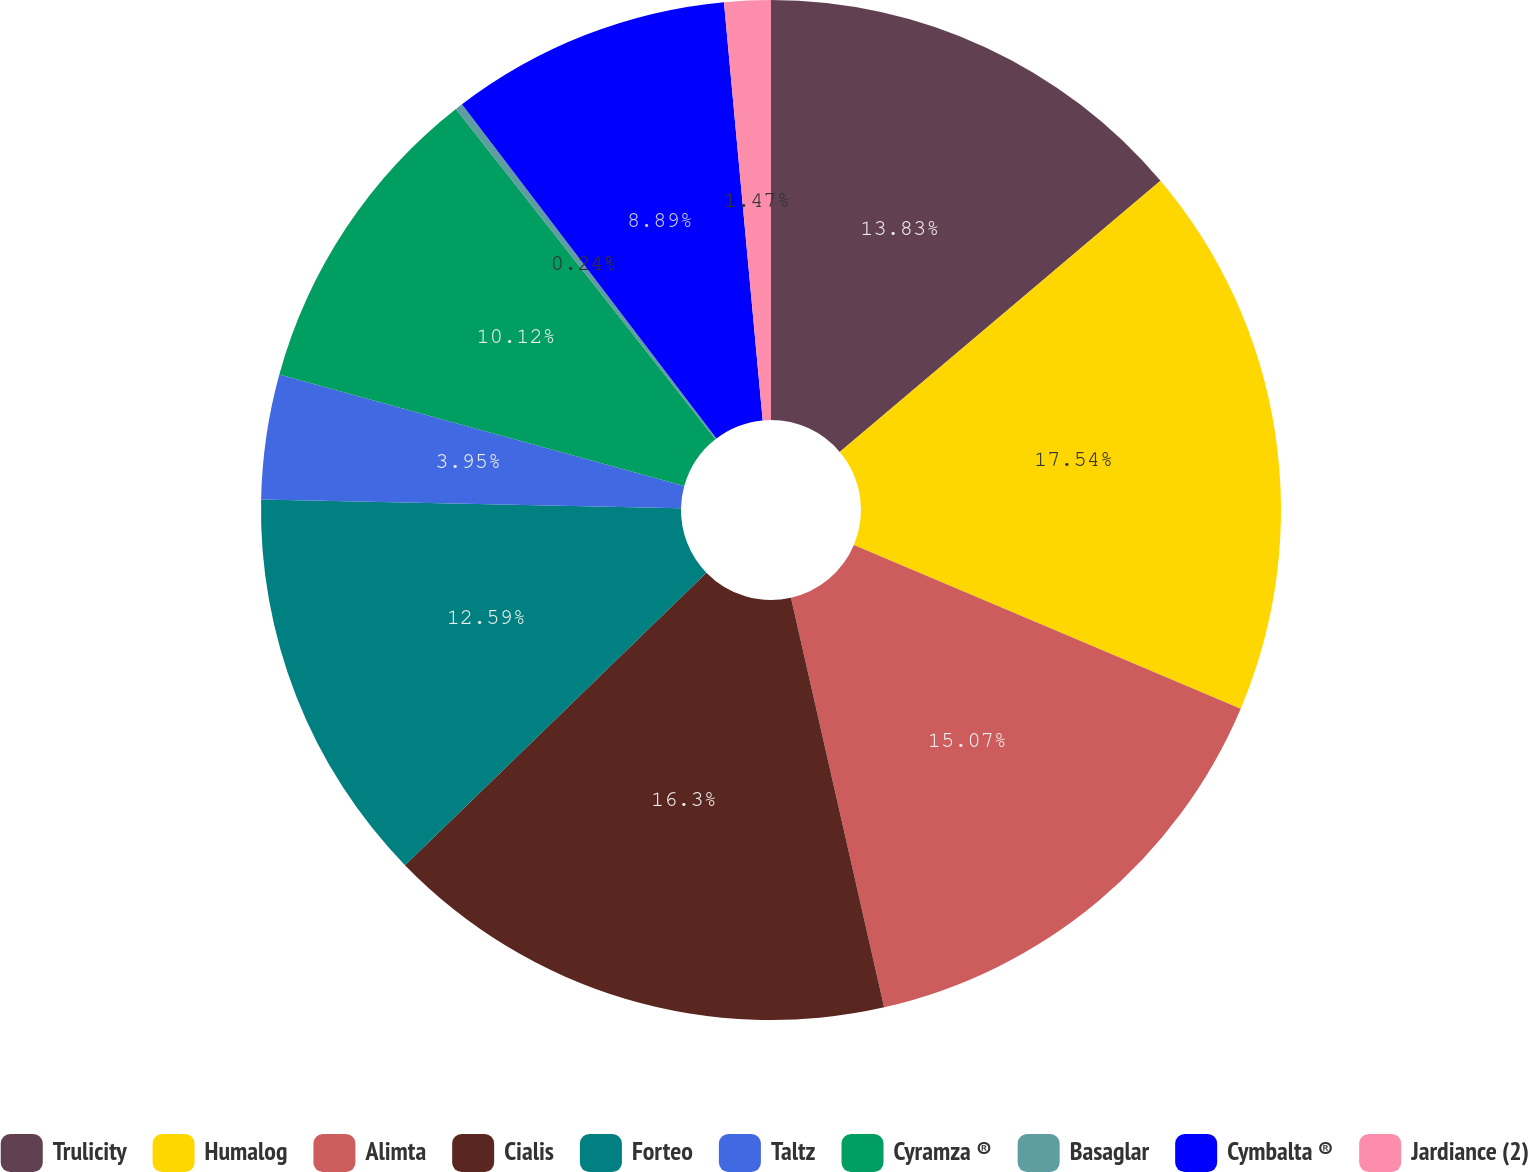<chart> <loc_0><loc_0><loc_500><loc_500><pie_chart><fcel>Trulicity<fcel>Humalog<fcel>Alimta<fcel>Cialis<fcel>Forteo<fcel>Taltz<fcel>Cyramza ®<fcel>Basaglar<fcel>Cymbalta ®<fcel>Jardiance (2)<nl><fcel>13.83%<fcel>17.54%<fcel>15.07%<fcel>16.3%<fcel>12.59%<fcel>3.95%<fcel>10.12%<fcel>0.24%<fcel>8.89%<fcel>1.47%<nl></chart> 